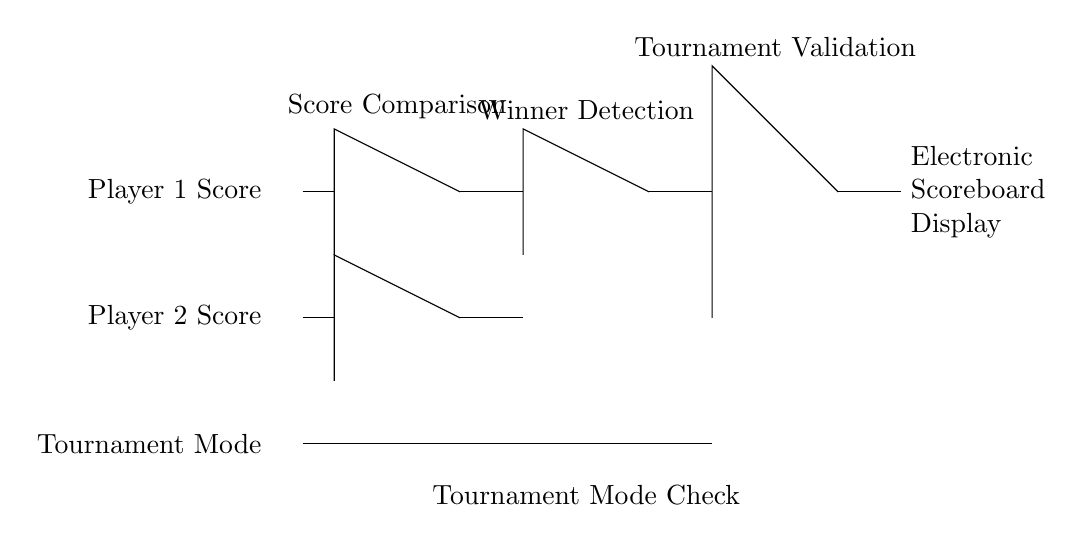What is the output of the circuit? The output of the circuit is directed to the electronic scoreboard display, which indicates the winner based on the input signals processed through the gates.
Answer: Electronic Scoreboard Display How many AND gates are present in the circuit? There are three AND gates in the diagram: two for score comparison and one for the final output.
Answer: Three What does the NOT gate represent in the circuit? The NOT gate represents an inversion of the tournament mode signal, which determines if the system is in tournament mode or not.
Answer: Tournament Mode Check Which gates are used to determine the winner? The logical operations that determine the winner involve the outputs from the two AND gates combined into an OR gate. The AND gates check conditions for each player's score, and the OR gate outputs the final winner.
Answer: AND and OR Gates What is the significance of the "Tournament Mode" input? The "Tournament Mode" input is crucial as it affects whether the system validates the scores processed; without being in tournament mode, the scoring decision is inverted, allowing it to function properly during tournament events only.
Answer: Tournament Validation 